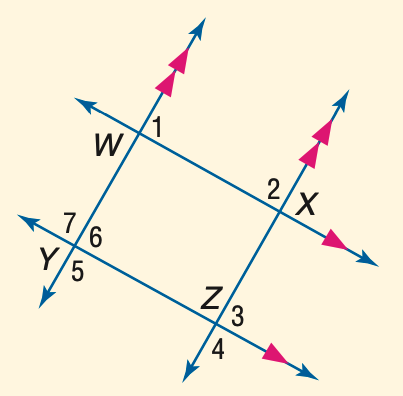Answer the mathemtical geometry problem and directly provide the correct option letter.
Question: In the figure, m \angle 1 = 3 a + 40, m \angle 2 = 2 a + 25, and m \angle 3 = 5 b - 26. Find b.
Choices: A: 21 B: 23 C: 25 D: 27 D 